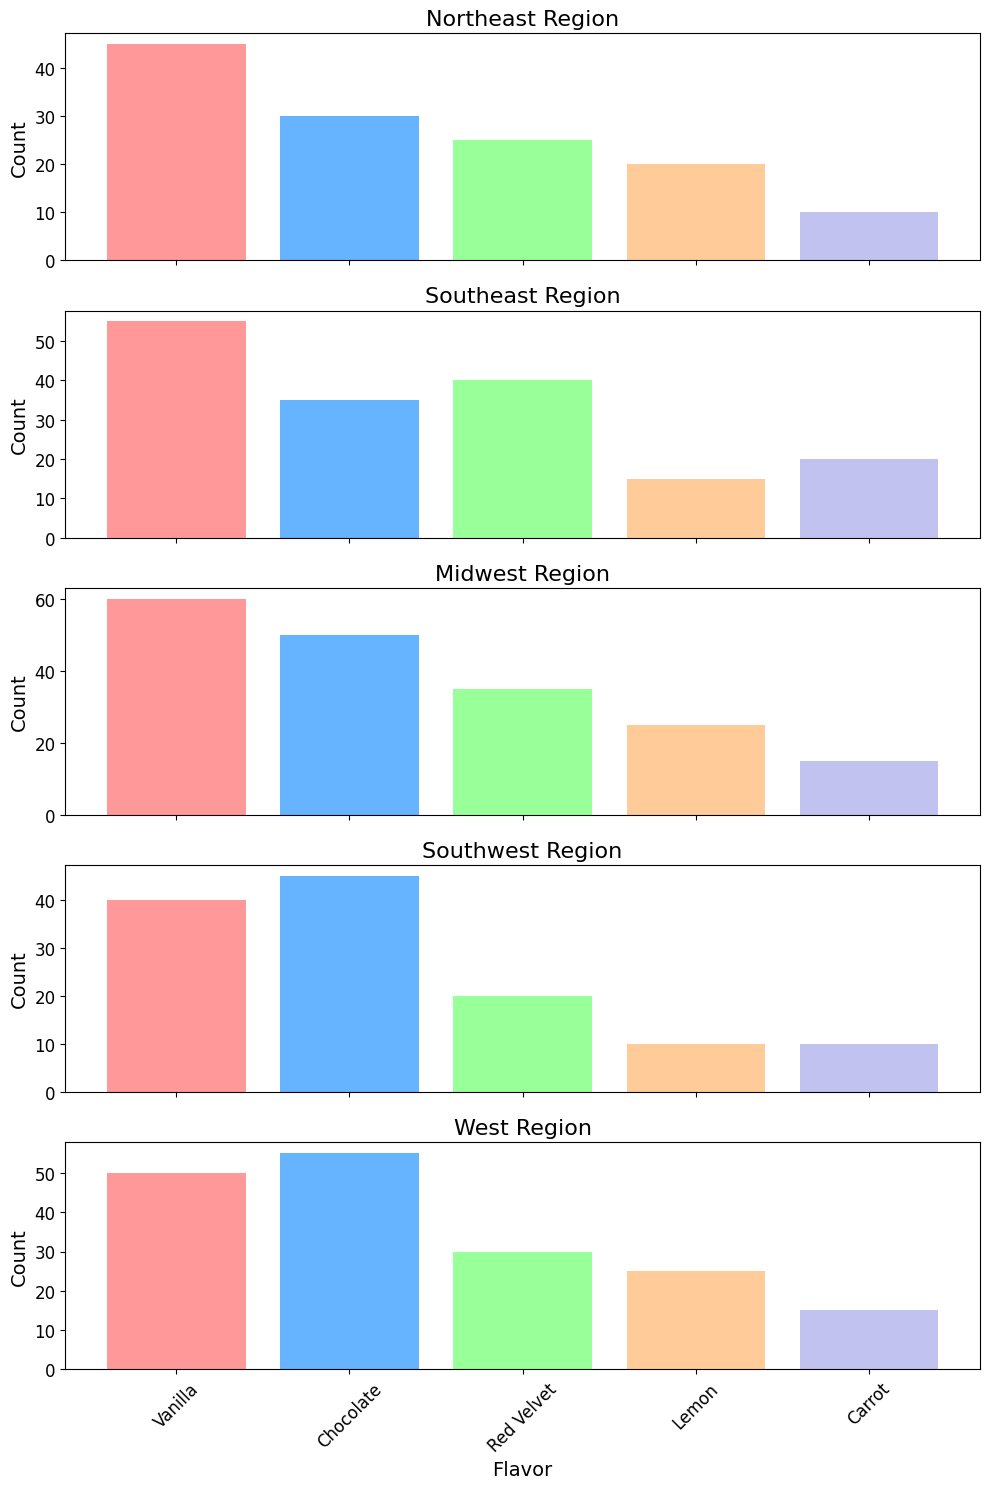What is the most popular cake flavor in the Midwest region? By looking at the height of the bars in the Midwest subplot, the Vanilla bar is the tallest. Hence, Vanilla is the most popular flavor.
Answer: Vanilla Which region has the highest count of Chocolate cake choices? By comparing the heights of the Chocolate bars across all regions, the West region has the tallest bar for Chocolate.
Answer: West What is the total count of Carrot cake choices in the Northeast and Southeast regions combined? The count for Carrot in the Northeast is 10 and in the Southeast is 20. Adding them together, 10 + 20 = 30.
Answer: 30 Which region shows the highest variability (difference between the highest and lowest counts) in cake flavor choices? To find the variability, we can subtract the lowest bar height from the highest bar height for each region. The Northeast region has the highest variability with a difference of 45 (highest, Vanilla) - 10 (lowest, Carrot and Lemon) = 35.
Answer: Northeast How does the popularity of Red Velvet cake in the Southwest compare to its popularity in the Midwest? The Red Velvet count in the Southwest is 20, whereas in the Midwest it is 35. Therefore, Red Velvet is more popular in the Midwest compared to the Southwest by 15.
Answer: Midwest Between the Northeast and the West, which region prefers Vanilla cake more? The count for Vanilla in the Northeast is 45, and in the West, it is 50. Thus, the West region prefers Vanilla cake more.
Answer: West What is the average count of Lemon cake choices across all regions? The counts for Lemon are Northeast: 20, Southeast: 15, Midwest: 25, Southwest: 10, West: 25. Summing these counts: 20 + 15 + 25 + 10 + 25 = 95. Dividing by the number of regions, 95 / 5 = 19.
Answer: 19 Is Chocolate cake more popular in the Southwest or the Southeast? Comparing the bar heights for Chocolate, the Southwest has a count of 45 while the Southeast has a count of 35. Hence, Chocolate is more popular in the Southwest.
Answer: Southwest 